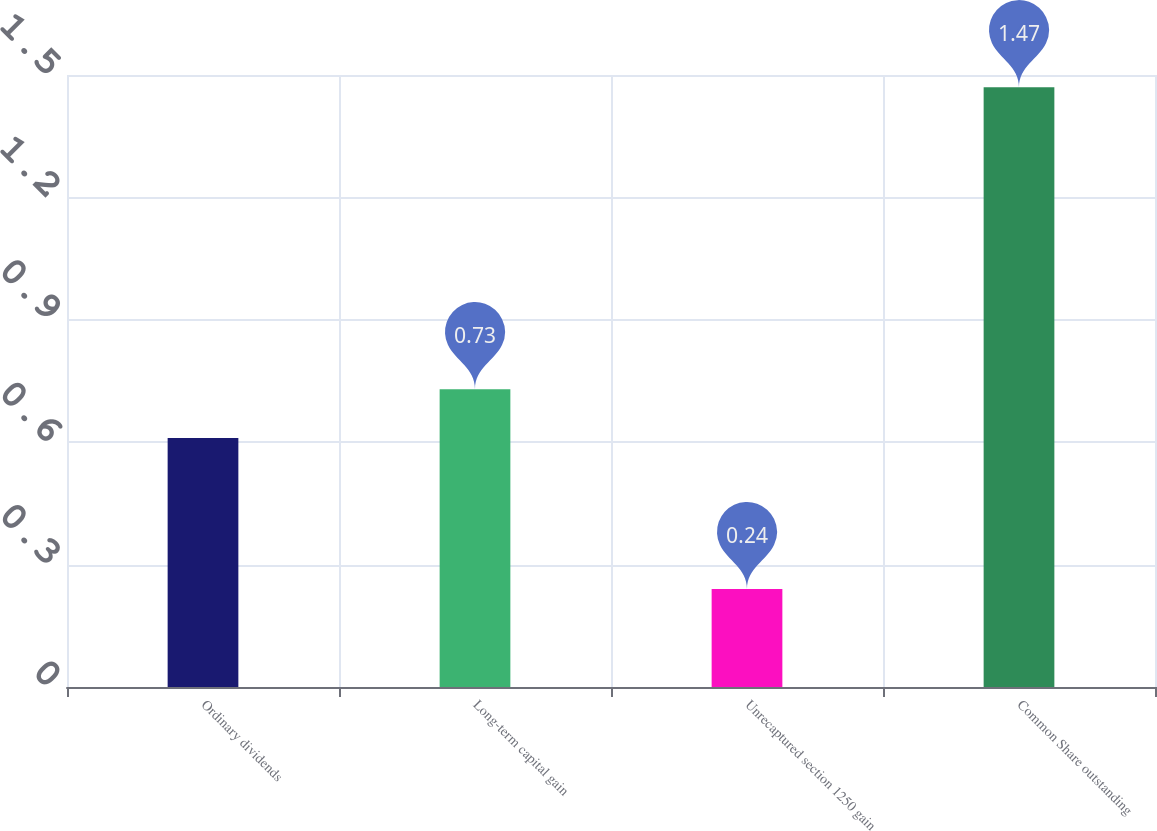Convert chart. <chart><loc_0><loc_0><loc_500><loc_500><bar_chart><fcel>Ordinary dividends<fcel>Long-term capital gain<fcel>Unrecaptured section 1250 gain<fcel>Common Share outstanding<nl><fcel>0.61<fcel>0.73<fcel>0.24<fcel>1.47<nl></chart> 